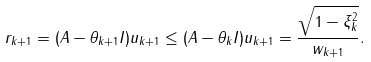Convert formula to latex. <formula><loc_0><loc_0><loc_500><loc_500>\| r _ { k + 1 } \| = \| ( A - \theta _ { k + 1 } I ) u _ { k + 1 } \| \leq \| ( A - \theta _ { k } I ) u _ { k + 1 } \| = \frac { \sqrt { 1 - \xi _ { k } ^ { 2 } } } { \| w _ { k + 1 } \| } .</formula> 